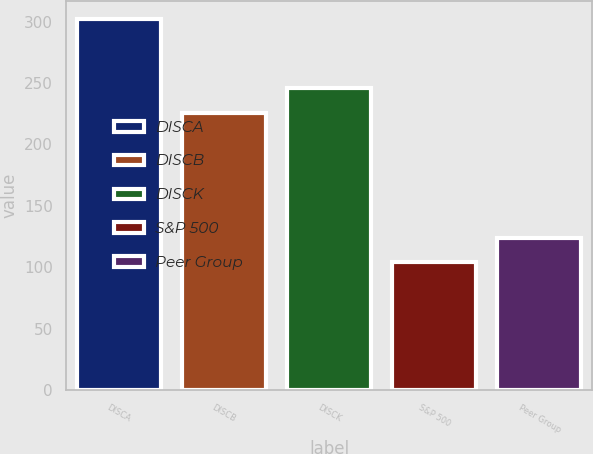Convert chart to OTSL. <chart><loc_0><loc_0><loc_500><loc_500><bar_chart><fcel>DISCA<fcel>DISCB<fcel>DISCK<fcel>S&P 500<fcel>Peer Group<nl><fcel>301.96<fcel>225.95<fcel>245.72<fcel>104.24<fcel>124.01<nl></chart> 